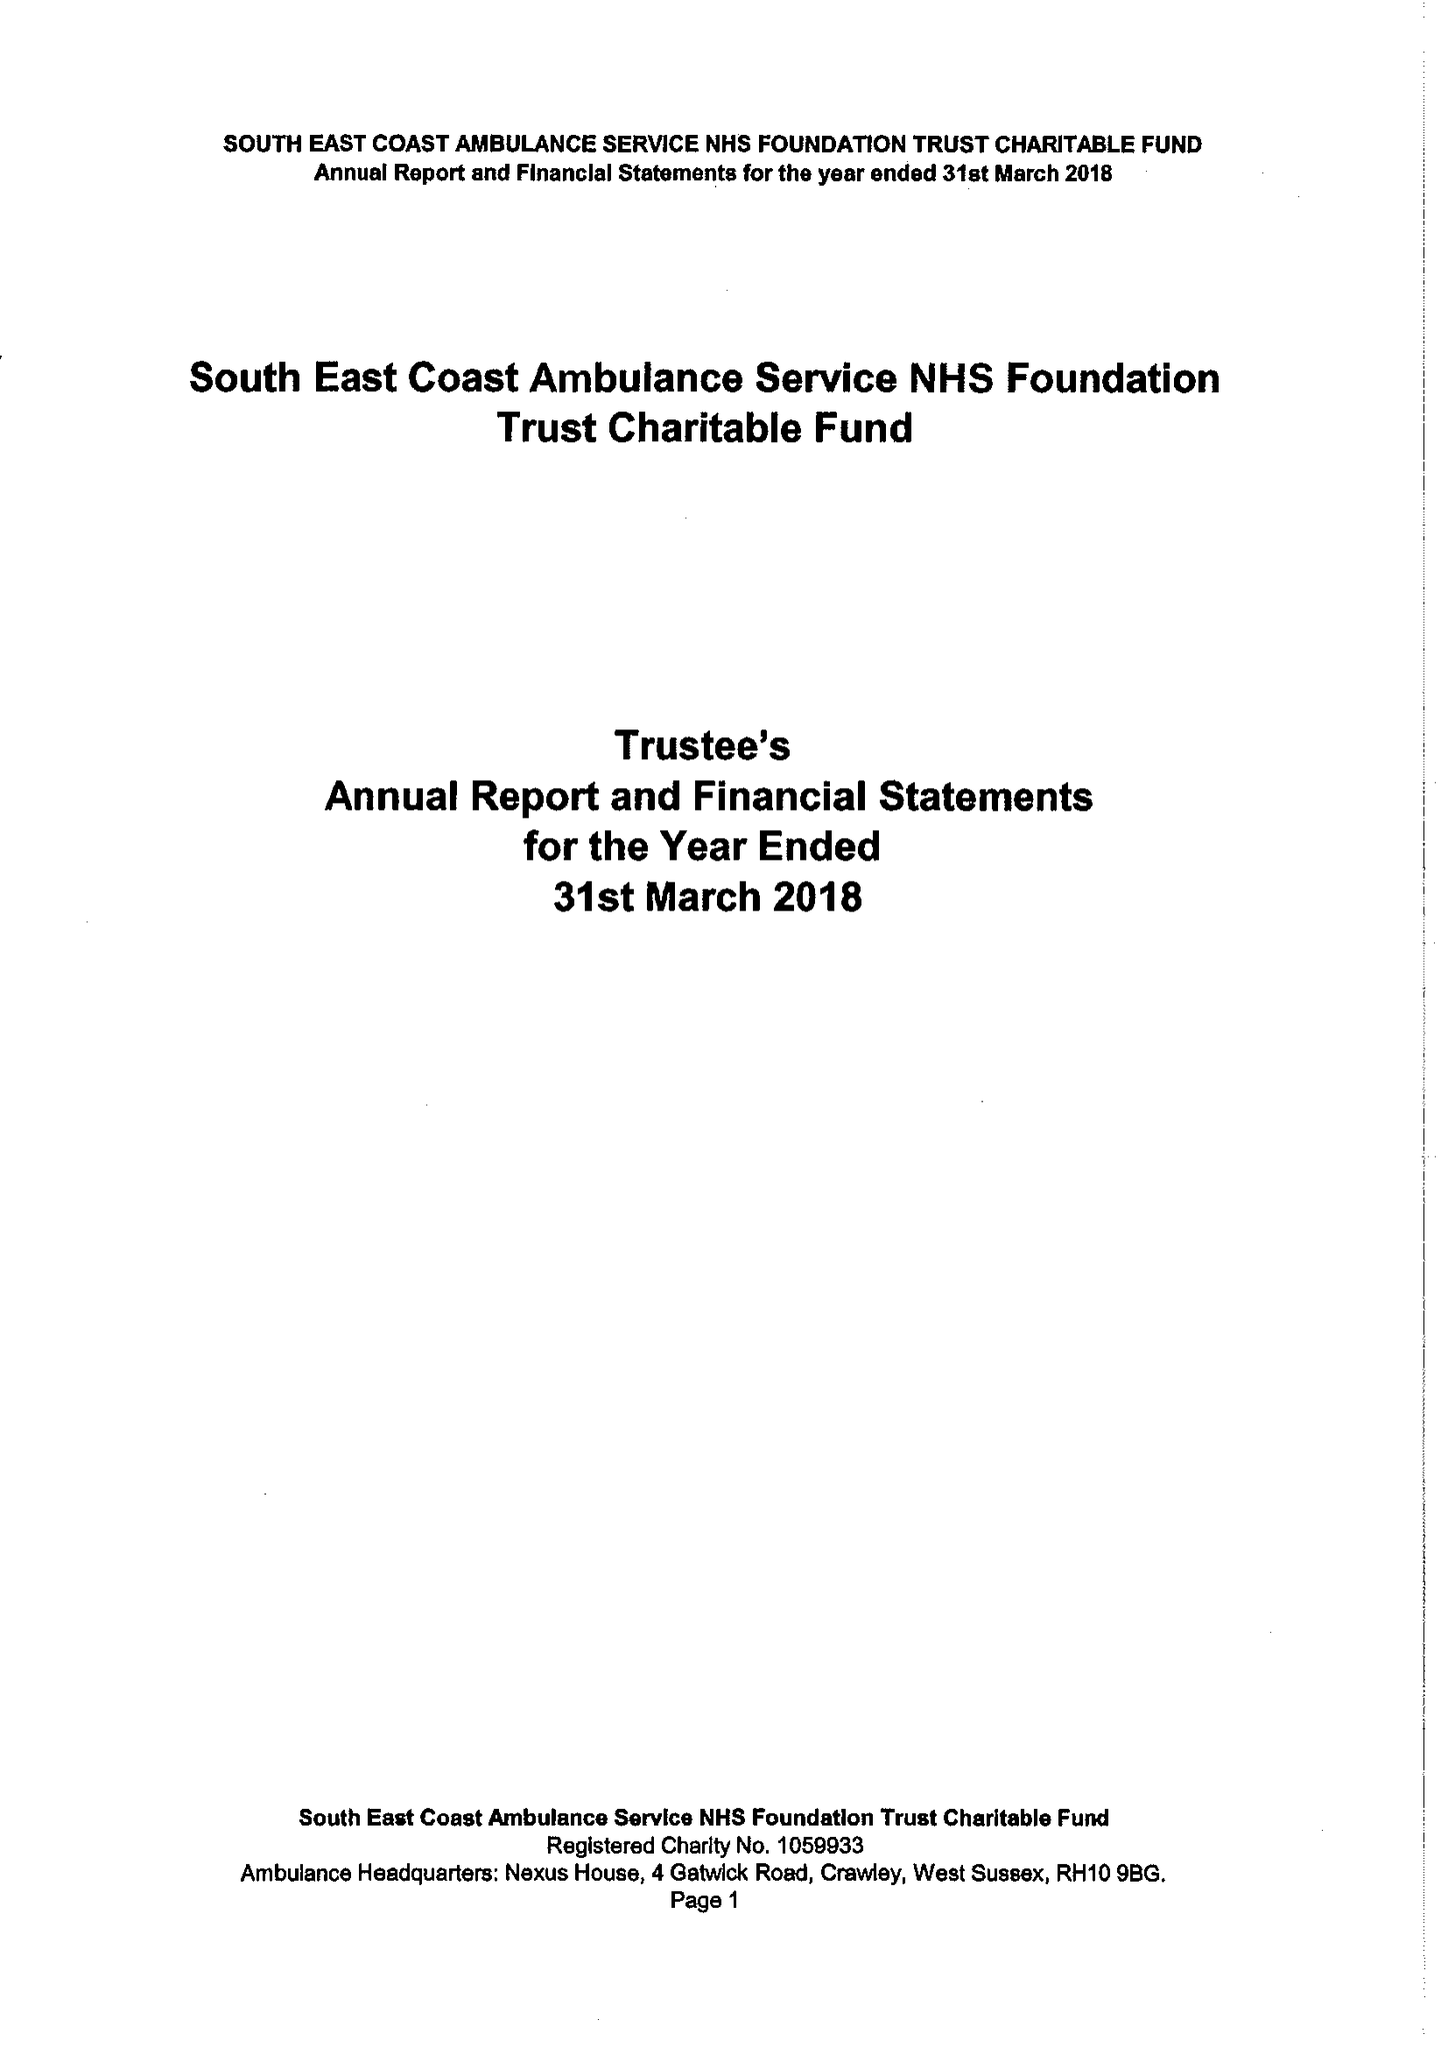What is the value for the charity_number?
Answer the question using a single word or phrase. 1059933 